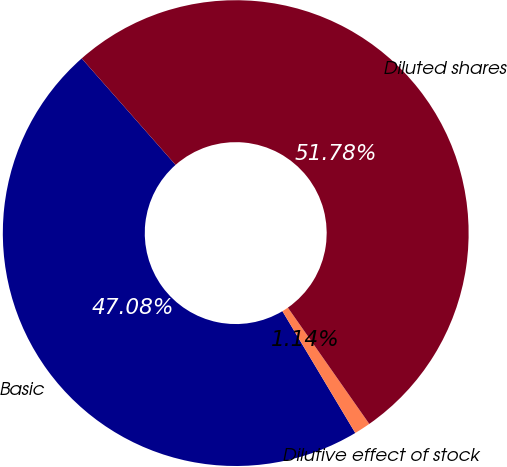Convert chart to OTSL. <chart><loc_0><loc_0><loc_500><loc_500><pie_chart><fcel>Basic<fcel>Dilutive effect of stock<fcel>Diluted shares<nl><fcel>47.08%<fcel>1.14%<fcel>51.78%<nl></chart> 